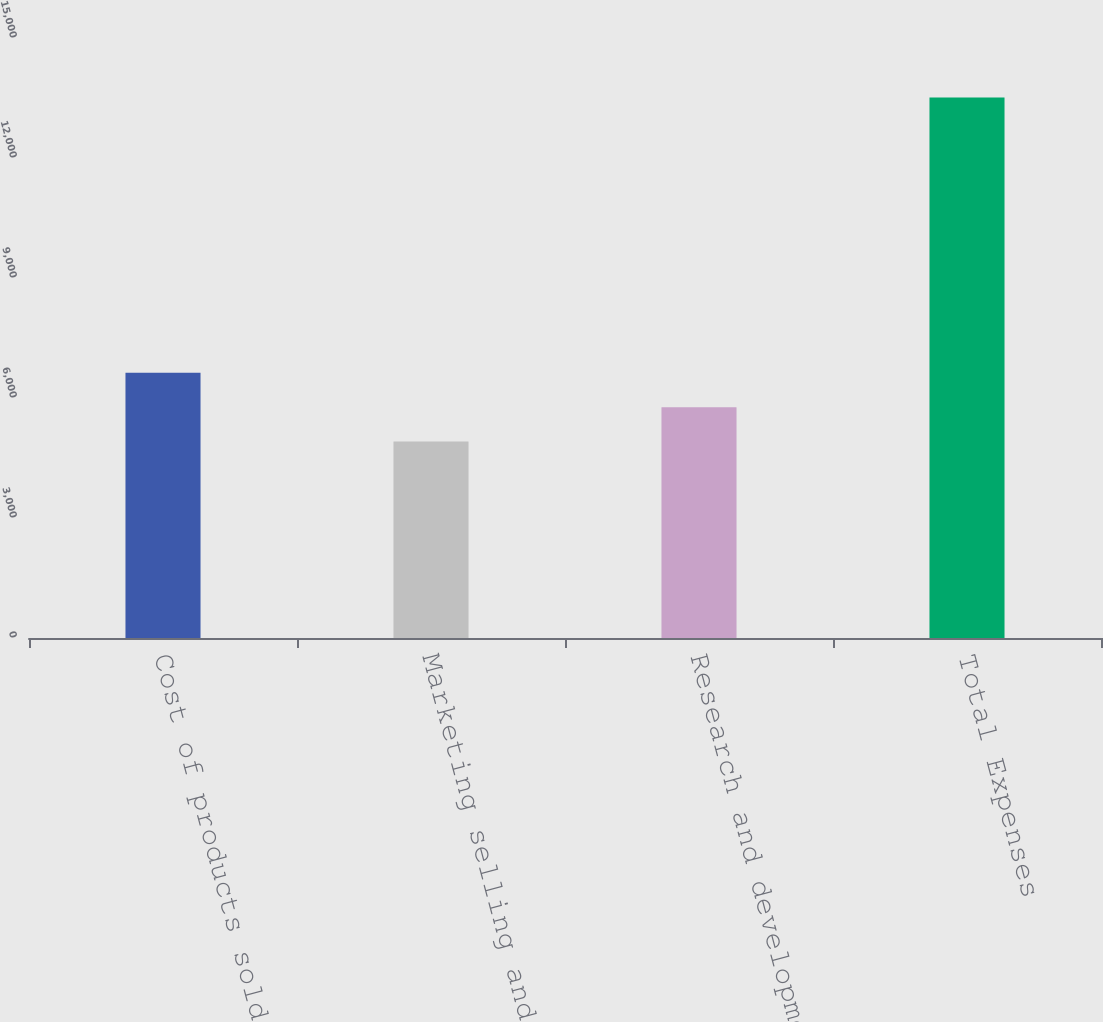Convert chart. <chart><loc_0><loc_0><loc_500><loc_500><bar_chart><fcel>Cost of products sold<fcel>Marketing selling and<fcel>Research and development<fcel>Total Expenses<nl><fcel>6631.2<fcel>4911<fcel>5771.1<fcel>13512<nl></chart> 